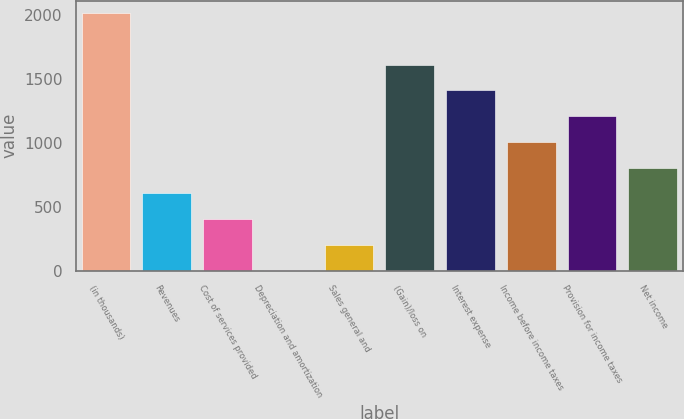<chart> <loc_0><loc_0><loc_500><loc_500><bar_chart><fcel>(in thousands)<fcel>Revenues<fcel>Cost of services provided<fcel>Depreciation and amortization<fcel>Sales general and<fcel>(Gain)/loss on<fcel>Interest expense<fcel>Income before income taxes<fcel>Provision for income taxes<fcel>Net income<nl><fcel>2011<fcel>605.4<fcel>404.6<fcel>3<fcel>203.8<fcel>1609.4<fcel>1408.6<fcel>1007<fcel>1207.8<fcel>806.2<nl></chart> 